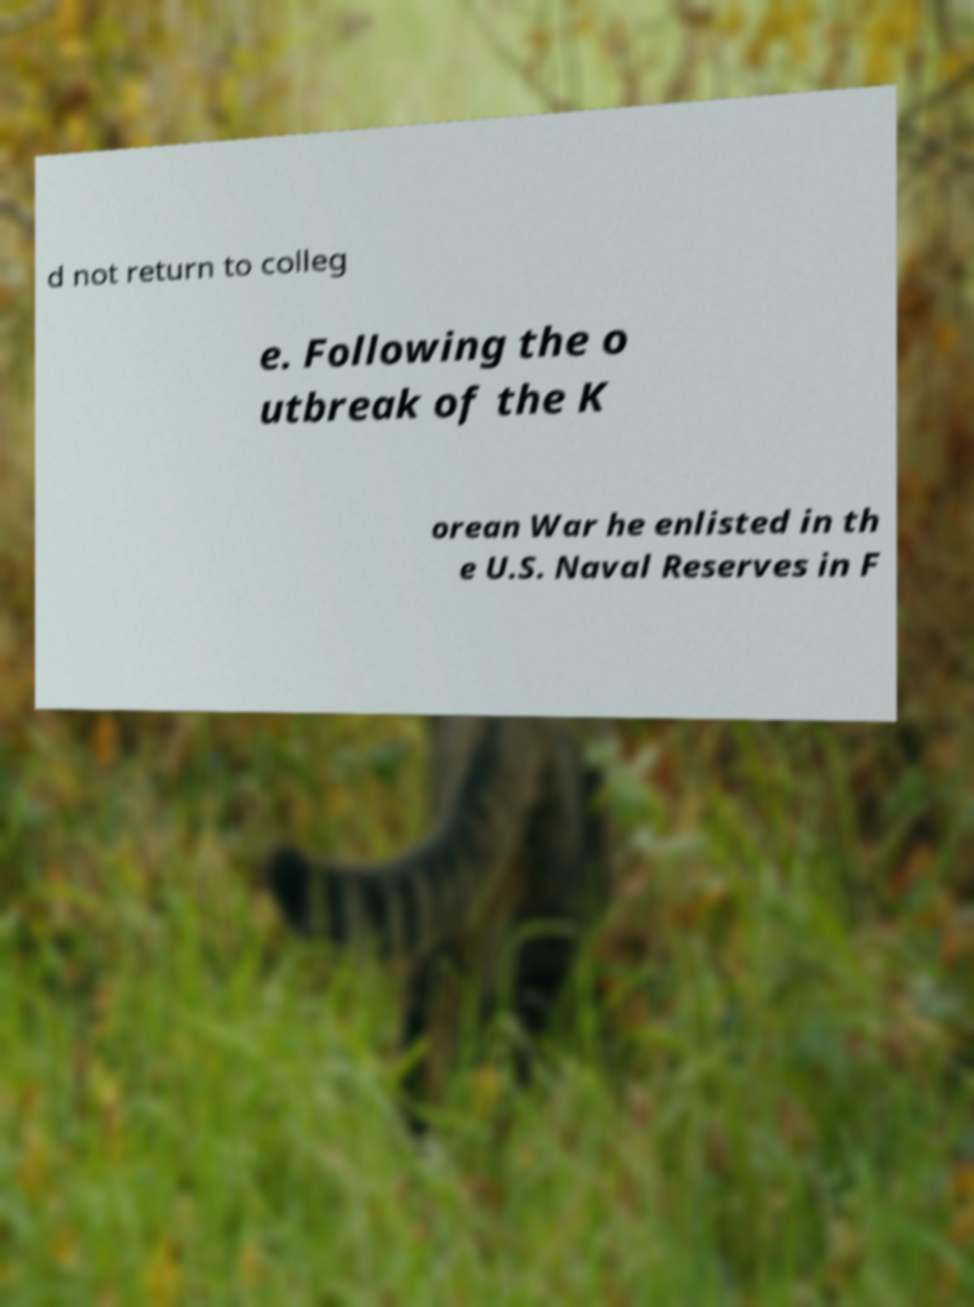What messages or text are displayed in this image? I need them in a readable, typed format. d not return to colleg e. Following the o utbreak of the K orean War he enlisted in th e U.S. Naval Reserves in F 